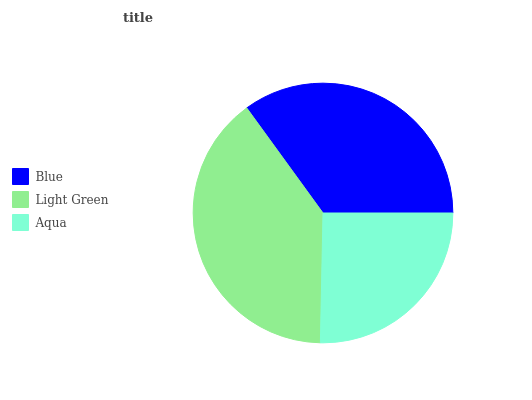Is Aqua the minimum?
Answer yes or no. Yes. Is Light Green the maximum?
Answer yes or no. Yes. Is Light Green the minimum?
Answer yes or no. No. Is Aqua the maximum?
Answer yes or no. No. Is Light Green greater than Aqua?
Answer yes or no. Yes. Is Aqua less than Light Green?
Answer yes or no. Yes. Is Aqua greater than Light Green?
Answer yes or no. No. Is Light Green less than Aqua?
Answer yes or no. No. Is Blue the high median?
Answer yes or no. Yes. Is Blue the low median?
Answer yes or no. Yes. Is Aqua the high median?
Answer yes or no. No. Is Aqua the low median?
Answer yes or no. No. 